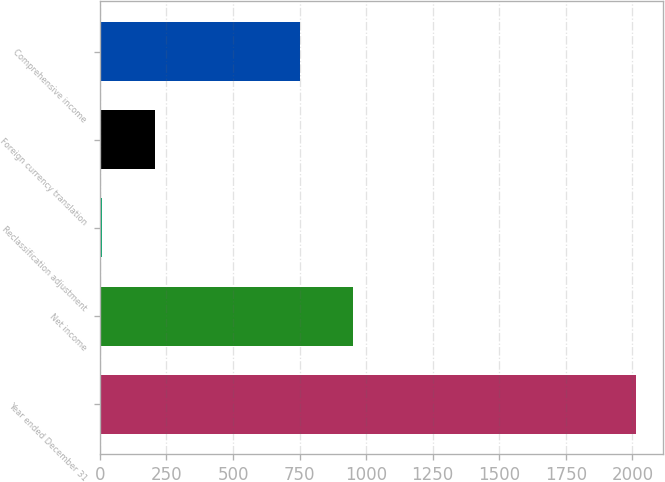<chart> <loc_0><loc_0><loc_500><loc_500><bar_chart><fcel>Year ended December 31<fcel>Net income<fcel>Reclassification adjustment<fcel>Foreign currency translation<fcel>Comprehensive income<nl><fcel>2014<fcel>951.6<fcel>8<fcel>208.6<fcel>751<nl></chart> 